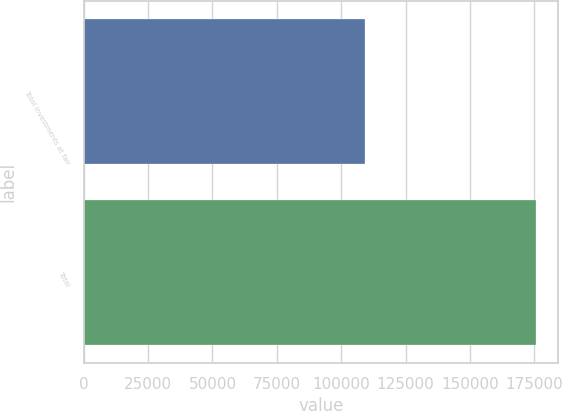<chart> <loc_0><loc_0><loc_500><loc_500><bar_chart><fcel>Total investments at fair<fcel>Total<nl><fcel>109403<fcel>175534<nl></chart> 